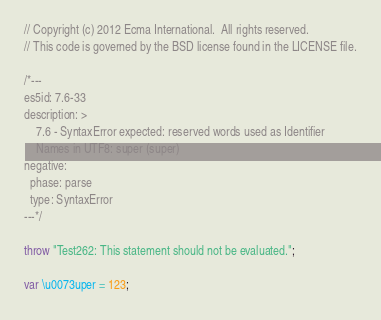Convert code to text. <code><loc_0><loc_0><loc_500><loc_500><_JavaScript_>// Copyright (c) 2012 Ecma International.  All rights reserved.
// This code is governed by the BSD license found in the LICENSE file.

/*---
es5id: 7.6-33
description: >
    7.6 - SyntaxError expected: reserved words used as Identifier
    Names in UTF8: super (super)
negative:
  phase: parse
  type: SyntaxError
---*/

throw "Test262: This statement should not be evaluated.";

var \u0073uper = 123;
</code> 